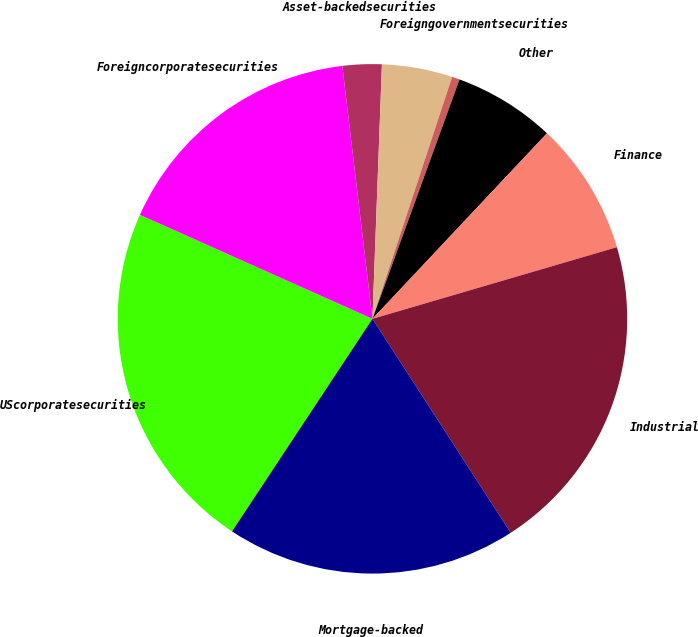<chart> <loc_0><loc_0><loc_500><loc_500><pie_chart><fcel>UScorporatesecurities<fcel>Foreigncorporatesecurities<fcel>Asset-backedsecurities<fcel>Unnamed: 3<fcel>Foreigngovernmentsecurities<fcel>Other<fcel>Finance<fcel>Industrial<fcel>Mortgage-backed<nl><fcel>22.4%<fcel>16.42%<fcel>2.48%<fcel>4.47%<fcel>0.49%<fcel>6.46%<fcel>8.45%<fcel>20.41%<fcel>18.42%<nl></chart> 